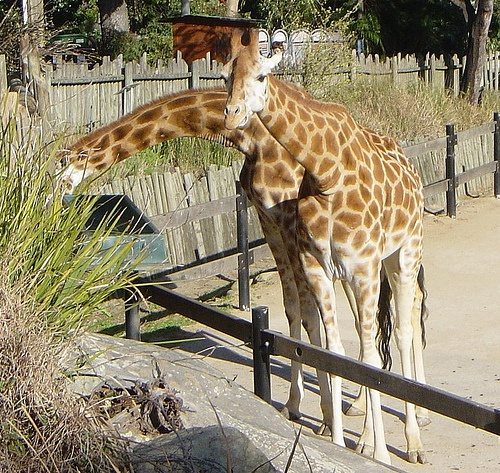Describe the objects in this image and their specific colors. I can see giraffe in lightblue, ivory, and tan tones and giraffe in lightblue, maroon, tan, and olive tones in this image. 